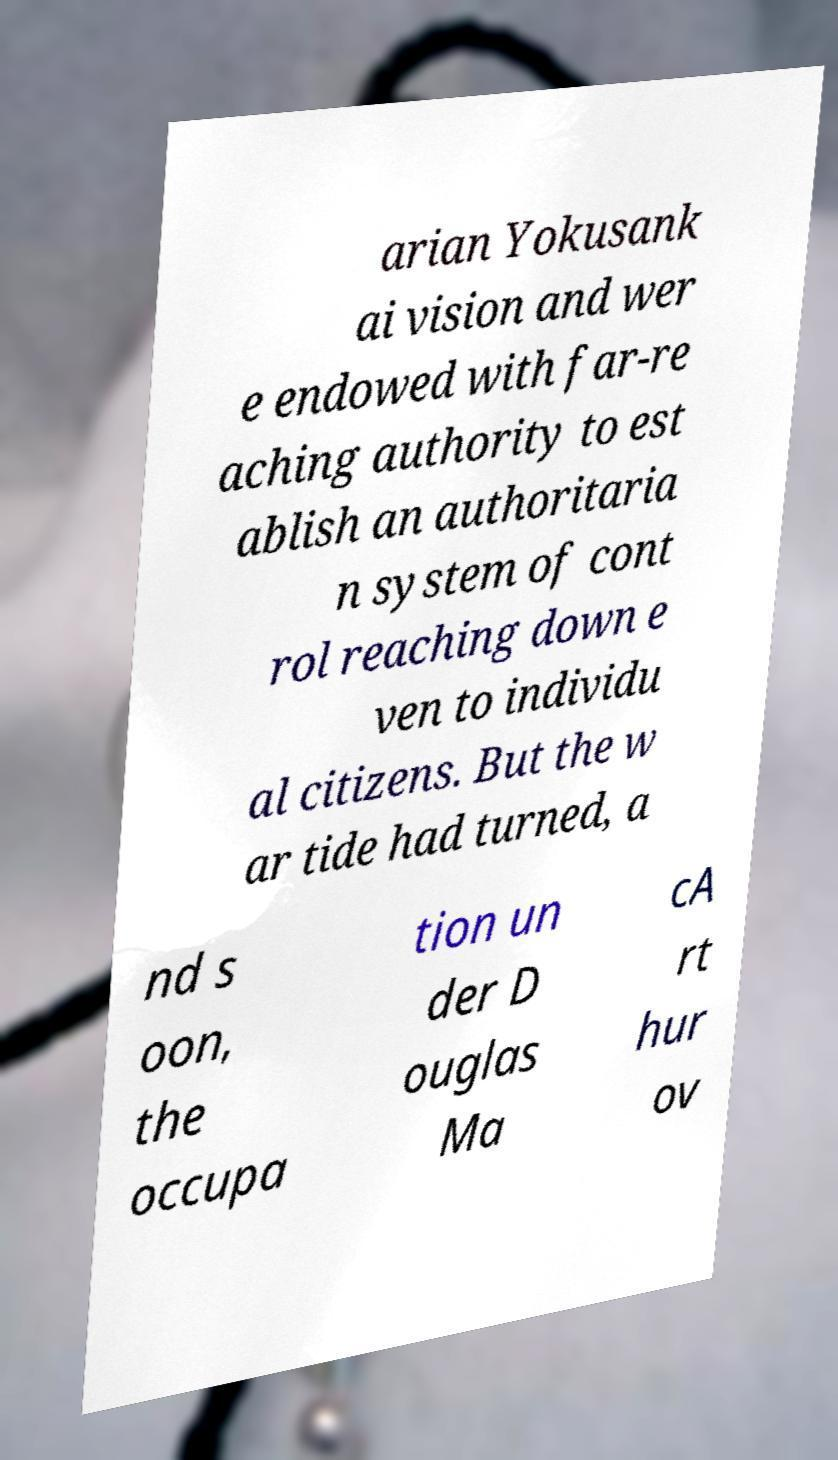Please read and relay the text visible in this image. What does it say? arian Yokusank ai vision and wer e endowed with far-re aching authority to est ablish an authoritaria n system of cont rol reaching down e ven to individu al citizens. But the w ar tide had turned, a nd s oon, the occupa tion un der D ouglas Ma cA rt hur ov 